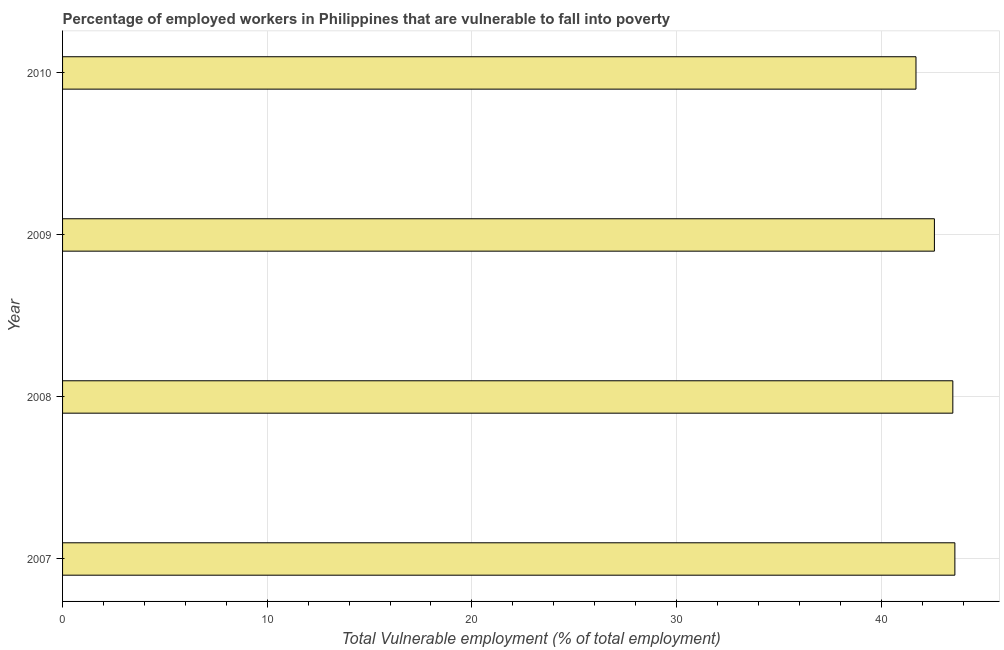Does the graph contain any zero values?
Give a very brief answer. No. Does the graph contain grids?
Give a very brief answer. Yes. What is the title of the graph?
Your answer should be very brief. Percentage of employed workers in Philippines that are vulnerable to fall into poverty. What is the label or title of the X-axis?
Give a very brief answer. Total Vulnerable employment (% of total employment). What is the total vulnerable employment in 2008?
Your answer should be compact. 43.5. Across all years, what is the maximum total vulnerable employment?
Your answer should be compact. 43.6. Across all years, what is the minimum total vulnerable employment?
Your answer should be compact. 41.7. What is the sum of the total vulnerable employment?
Provide a succinct answer. 171.4. What is the average total vulnerable employment per year?
Ensure brevity in your answer.  42.85. What is the median total vulnerable employment?
Ensure brevity in your answer.  43.05. Do a majority of the years between 2008 and 2009 (inclusive) have total vulnerable employment greater than 28 %?
Ensure brevity in your answer.  Yes. What is the ratio of the total vulnerable employment in 2008 to that in 2010?
Ensure brevity in your answer.  1.04. Is the difference between the total vulnerable employment in 2009 and 2010 greater than the difference between any two years?
Your answer should be very brief. No. What is the difference between the highest and the second highest total vulnerable employment?
Your response must be concise. 0.1. How many bars are there?
Offer a terse response. 4. Are all the bars in the graph horizontal?
Your response must be concise. Yes. Are the values on the major ticks of X-axis written in scientific E-notation?
Provide a short and direct response. No. What is the Total Vulnerable employment (% of total employment) of 2007?
Provide a short and direct response. 43.6. What is the Total Vulnerable employment (% of total employment) of 2008?
Offer a terse response. 43.5. What is the Total Vulnerable employment (% of total employment) in 2009?
Keep it short and to the point. 42.6. What is the Total Vulnerable employment (% of total employment) of 2010?
Provide a succinct answer. 41.7. What is the difference between the Total Vulnerable employment (% of total employment) in 2007 and 2008?
Make the answer very short. 0.1. What is the difference between the Total Vulnerable employment (% of total employment) in 2007 and 2009?
Make the answer very short. 1. What is the difference between the Total Vulnerable employment (% of total employment) in 2008 and 2009?
Provide a succinct answer. 0.9. What is the difference between the Total Vulnerable employment (% of total employment) in 2008 and 2010?
Provide a succinct answer. 1.8. What is the ratio of the Total Vulnerable employment (% of total employment) in 2007 to that in 2008?
Ensure brevity in your answer.  1. What is the ratio of the Total Vulnerable employment (% of total employment) in 2007 to that in 2009?
Keep it short and to the point. 1.02. What is the ratio of the Total Vulnerable employment (% of total employment) in 2007 to that in 2010?
Provide a succinct answer. 1.05. What is the ratio of the Total Vulnerable employment (% of total employment) in 2008 to that in 2010?
Make the answer very short. 1.04. What is the ratio of the Total Vulnerable employment (% of total employment) in 2009 to that in 2010?
Ensure brevity in your answer.  1.02. 